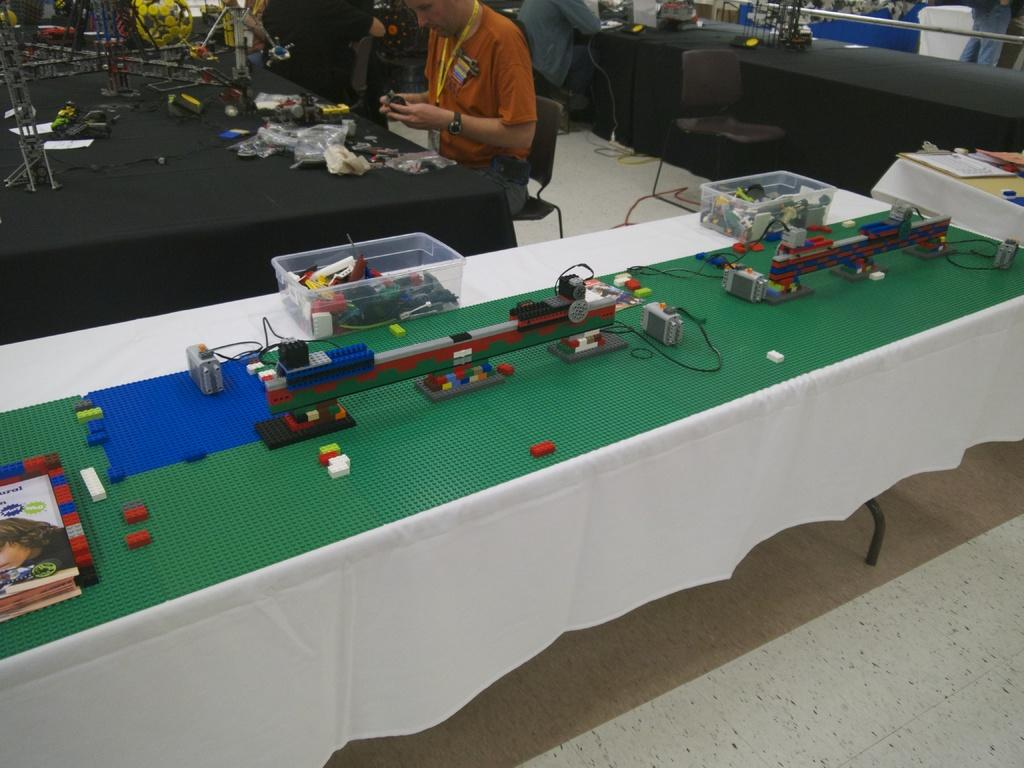What type of furniture is present in the image? There are tables in the image. What objects can be seen on the tables? There are blocks, boxes, and books on the tables. Are there any other items on the tables? Yes, there are other unspecified things placed on the tables. What can be observed about the people in the image? There are people sitting in the image. What is visible at the bottom of the image? There is a floor visible at the bottom of the image. What type of food is being served on the tables in the image? There is no food visible on the tables in the image. Can you tell me what the aunt of the person sitting at the table is doing in the image? There is no mention of an aunt or any specific person in the image, so it is not possible to answer this question. 